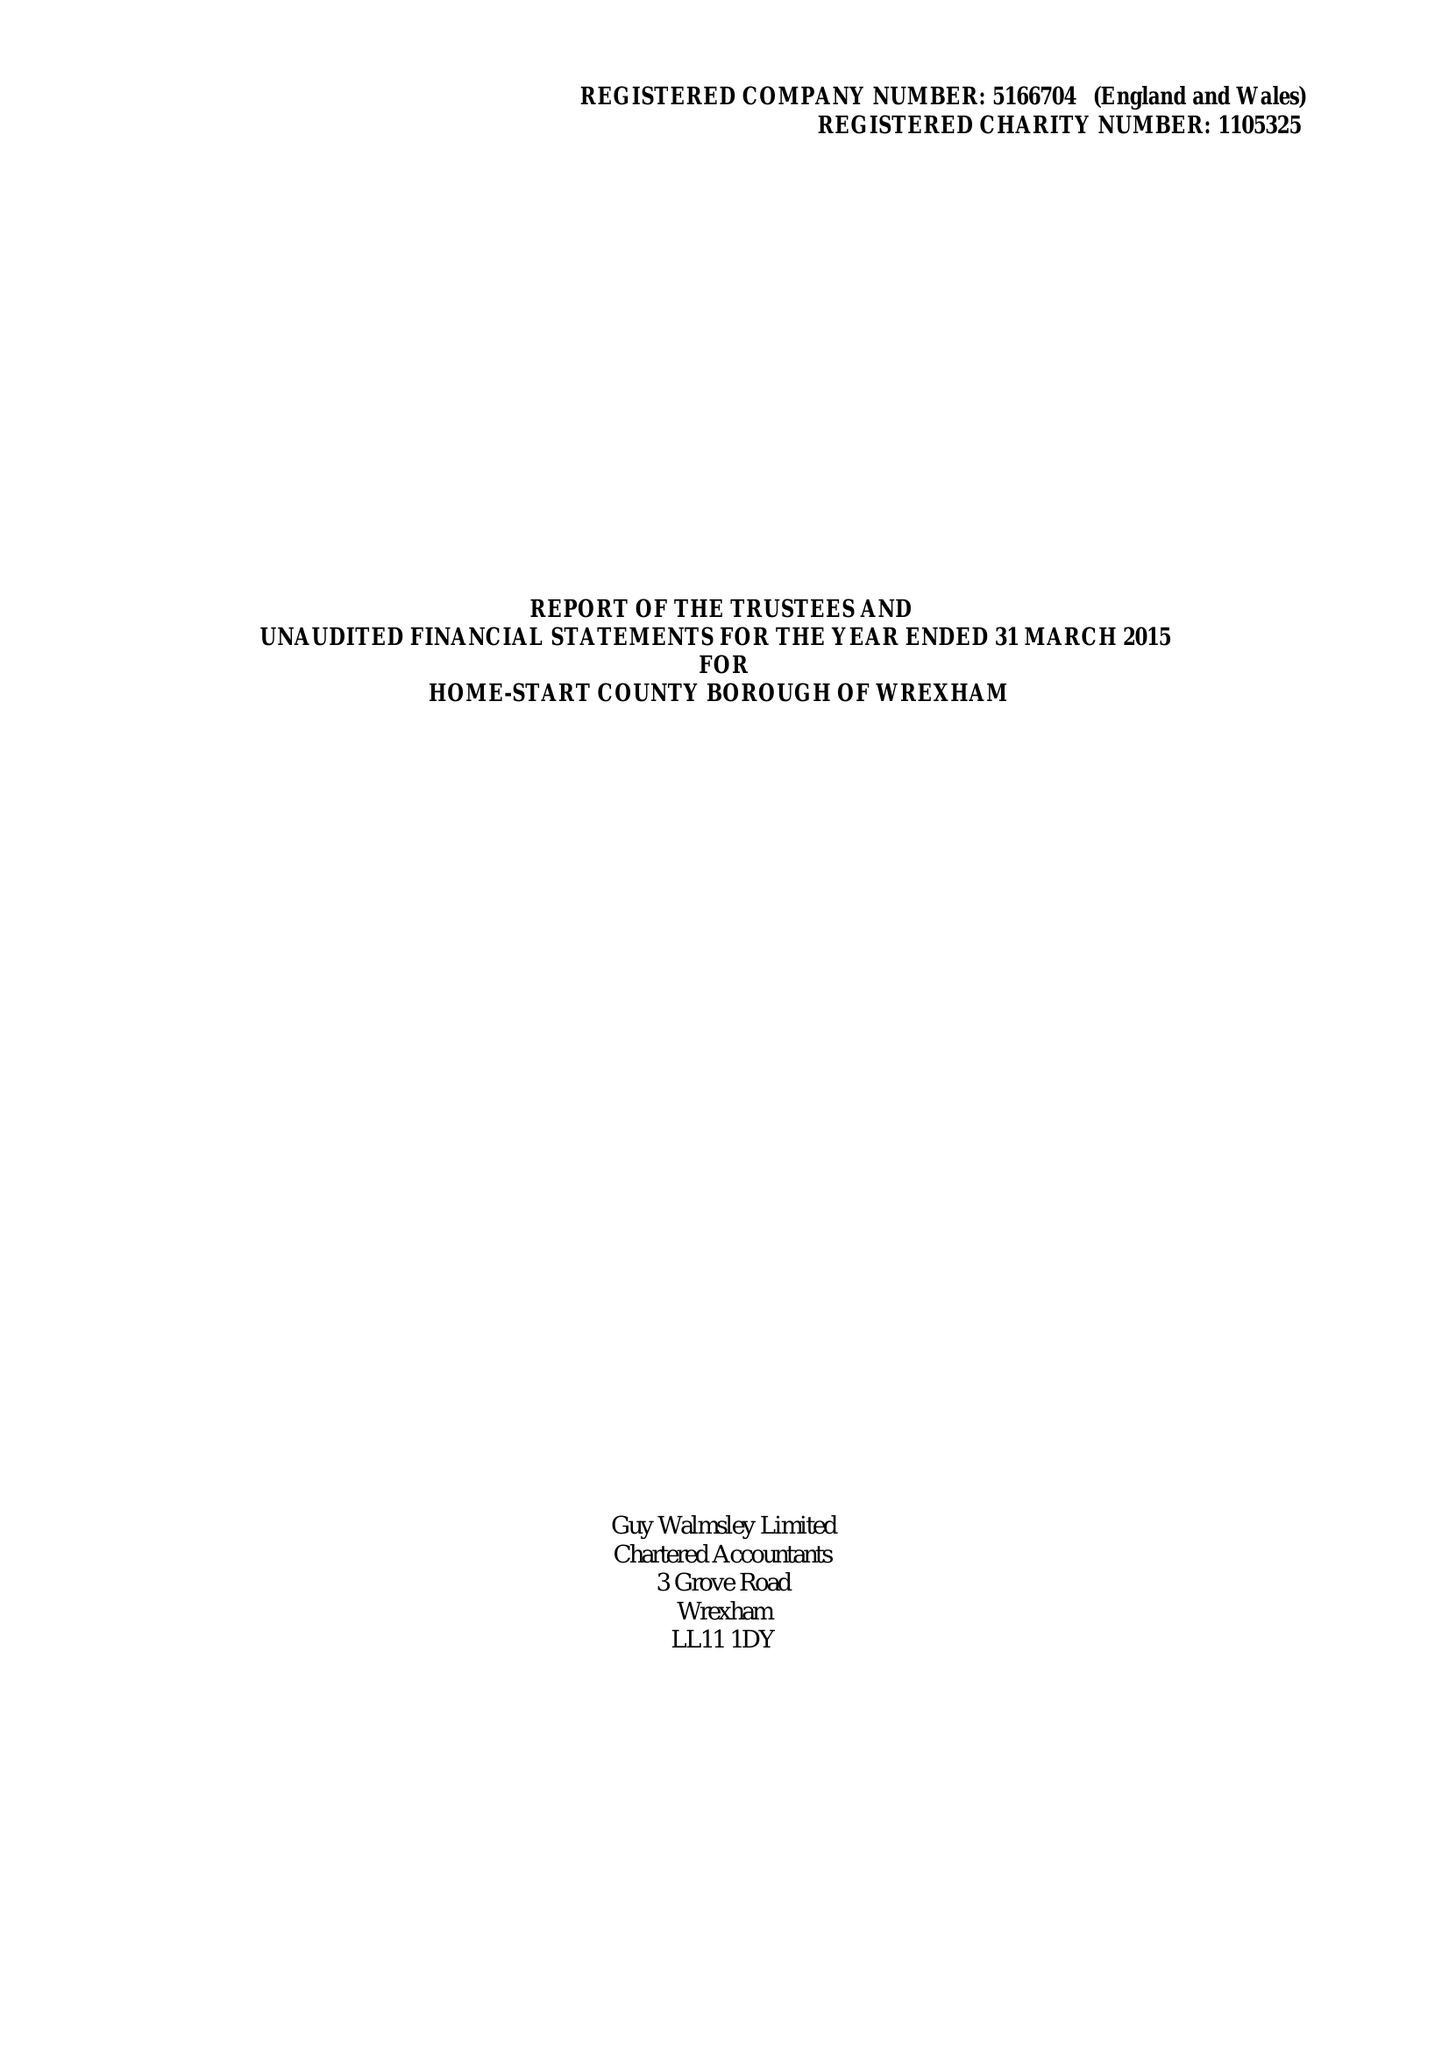What is the value for the address__street_line?
Answer the question using a single word or phrase. GARDEN ROAD 